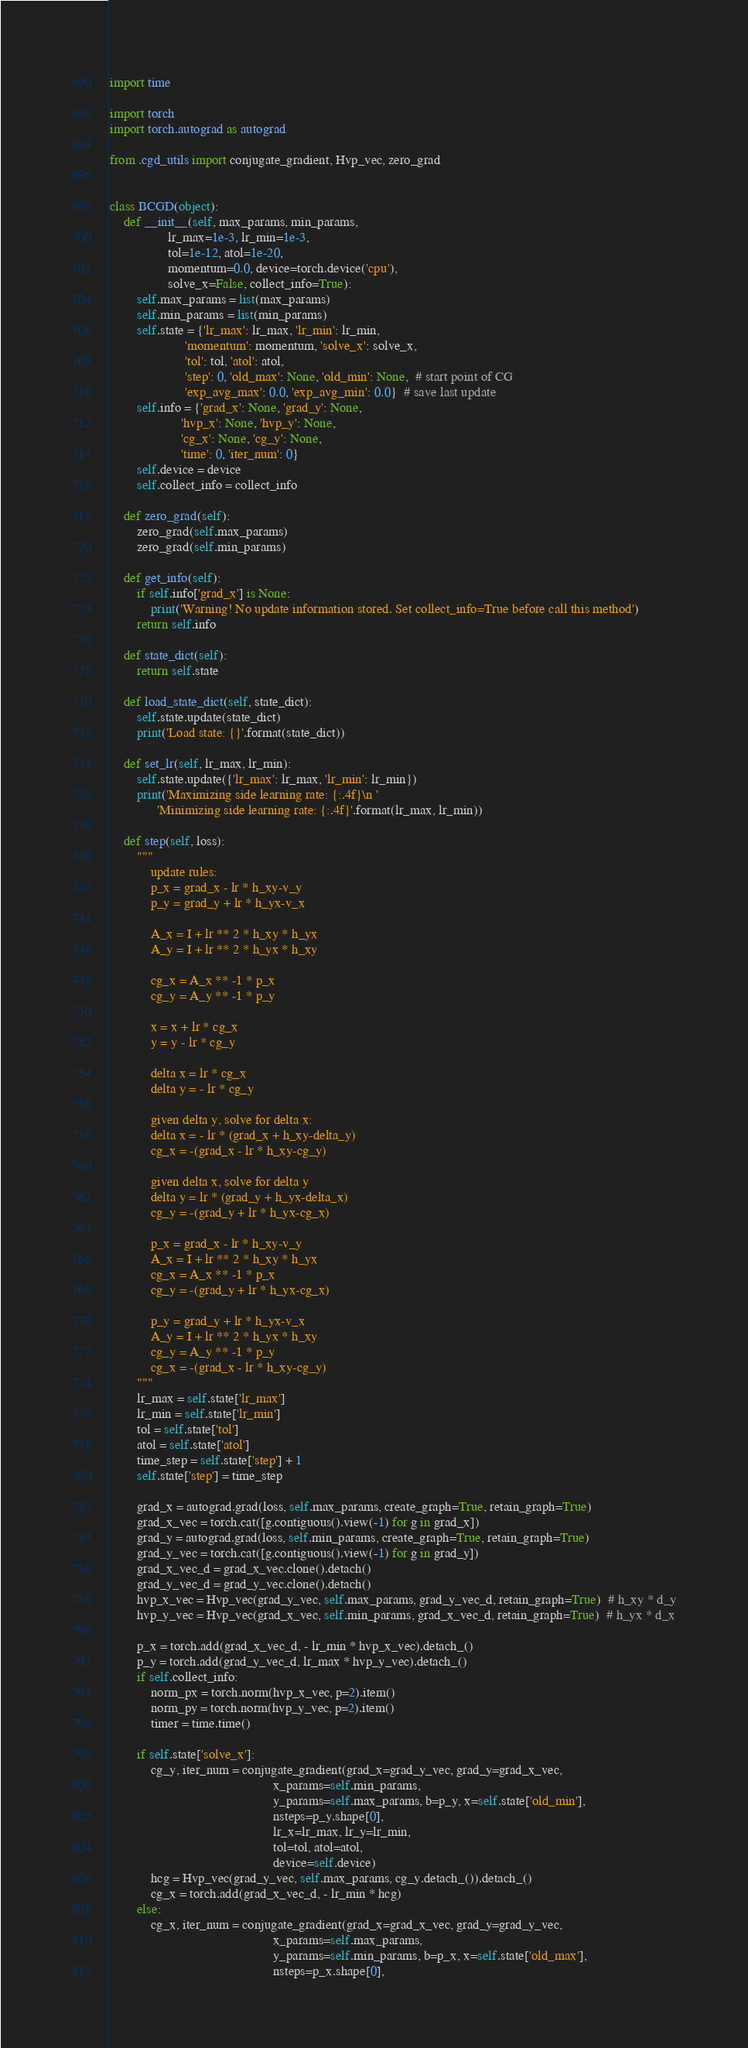Convert code to text. <code><loc_0><loc_0><loc_500><loc_500><_Python_>import time

import torch
import torch.autograd as autograd

from .cgd_utils import conjugate_gradient, Hvp_vec, zero_grad


class BCGD(object):
    def __init__(self, max_params, min_params,
                 lr_max=1e-3, lr_min=1e-3,
                 tol=1e-12, atol=1e-20,
                 momentum=0.0, device=torch.device('cpu'),
                 solve_x=False, collect_info=True):
        self.max_params = list(max_params)
        self.min_params = list(min_params)
        self.state = {'lr_max': lr_max, 'lr_min': lr_min,
                      'momentum': momentum, 'solve_x': solve_x,
                      'tol': tol, 'atol': atol,
                      'step': 0, 'old_max': None, 'old_min': None,  # start point of CG
                      'exp_avg_max': 0.0, 'exp_avg_min': 0.0}  # save last update
        self.info = {'grad_x': None, 'grad_y': None,
                     'hvp_x': None, 'hvp_y': None,
                     'cg_x': None, 'cg_y': None,
                     'time': 0, 'iter_num': 0}
        self.device = device
        self.collect_info = collect_info

    def zero_grad(self):
        zero_grad(self.max_params)
        zero_grad(self.min_params)

    def get_info(self):
        if self.info['grad_x'] is None:
            print('Warning! No update information stored. Set collect_info=True before call this method')
        return self.info

    def state_dict(self):
        return self.state

    def load_state_dict(self, state_dict):
        self.state.update(state_dict)
        print('Load state: {}'.format(state_dict))

    def set_lr(self, lr_max, lr_min):
        self.state.update({'lr_max': lr_max, 'lr_min': lr_min})
        print('Maximizing side learning rate: {:.4f}\n '
              'Minimizing side learning rate: {:.4f}'.format(lr_max, lr_min))

    def step(self, loss):
        """
            update rules:
            p_x = grad_x - lr * h_xy-v_y
            p_y = grad_y + lr * h_yx-v_x

            A_x = I + lr ** 2 * h_xy * h_yx
            A_y = I + lr ** 2 * h_yx * h_xy

            cg_x = A_x ** -1 * p_x
            cg_y = A_y ** -1 * p_y

            x = x + lr * cg_x
            y = y - lr * cg_y

            delta x = lr * cg_x
            delta y = - lr * cg_y

            given delta y, solve for delta x:
            delta x = - lr * (grad_x + h_xy-delta_y)
            cg_x = -(grad_x - lr * h_xy-cg_y)

            given delta x, solve for delta y
            delta y = lr * (grad_y + h_yx-delta_x)
            cg_y = -(grad_y + lr * h_yx-cg_x)

            p_x = grad_x - lr * h_xy-v_y
            A_x = I + lr ** 2 * h_xy * h_yx
            cg_x = A_x ** -1 * p_x
            cg_y = -(grad_y + lr * h_yx-cg_x)

            p_y = grad_y + lr * h_yx-v_x
            A_y = I + lr ** 2 * h_yx * h_xy
            cg_y = A_y ** -1 * p_y
            cg_x = -(grad_x - lr * h_xy-cg_y)
        """
        lr_max = self.state['lr_max']
        lr_min = self.state['lr_min']
        tol = self.state['tol']
        atol = self.state['atol']
        time_step = self.state['step'] + 1
        self.state['step'] = time_step

        grad_x = autograd.grad(loss, self.max_params, create_graph=True, retain_graph=True)
        grad_x_vec = torch.cat([g.contiguous().view(-1) for g in grad_x])
        grad_y = autograd.grad(loss, self.min_params, create_graph=True, retain_graph=True)
        grad_y_vec = torch.cat([g.contiguous().view(-1) for g in grad_y])
        grad_x_vec_d = grad_x_vec.clone().detach()
        grad_y_vec_d = grad_y_vec.clone().detach()
        hvp_x_vec = Hvp_vec(grad_y_vec, self.max_params, grad_y_vec_d, retain_graph=True)  # h_xy * d_y
        hvp_y_vec = Hvp_vec(grad_x_vec, self.min_params, grad_x_vec_d, retain_graph=True)  # h_yx * d_x

        p_x = torch.add(grad_x_vec_d, - lr_min * hvp_x_vec).detach_()
        p_y = torch.add(grad_y_vec_d, lr_max * hvp_y_vec).detach_()
        if self.collect_info:
            norm_px = torch.norm(hvp_x_vec, p=2).item()
            norm_py = torch.norm(hvp_y_vec, p=2).item()
            timer = time.time()

        if self.state['solve_x']:
            cg_y, iter_num = conjugate_gradient(grad_x=grad_y_vec, grad_y=grad_x_vec,
                                                x_params=self.min_params,
                                                y_params=self.max_params, b=p_y, x=self.state['old_min'],
                                                nsteps=p_y.shape[0],
                                                lr_x=lr_max, lr_y=lr_min,
                                                tol=tol, atol=atol,
                                                device=self.device)
            hcg = Hvp_vec(grad_y_vec, self.max_params, cg_y.detach_()).detach_()
            cg_x = torch.add(grad_x_vec_d, - lr_min * hcg)
        else:
            cg_x, iter_num = conjugate_gradient(grad_x=grad_x_vec, grad_y=grad_y_vec,
                                                x_params=self.max_params,
                                                y_params=self.min_params, b=p_x, x=self.state['old_max'],
                                                nsteps=p_x.shape[0],</code> 